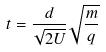<formula> <loc_0><loc_0><loc_500><loc_500>t = \frac { d } { \sqrt { 2 U } } \sqrt { \frac { m } { q } }</formula> 